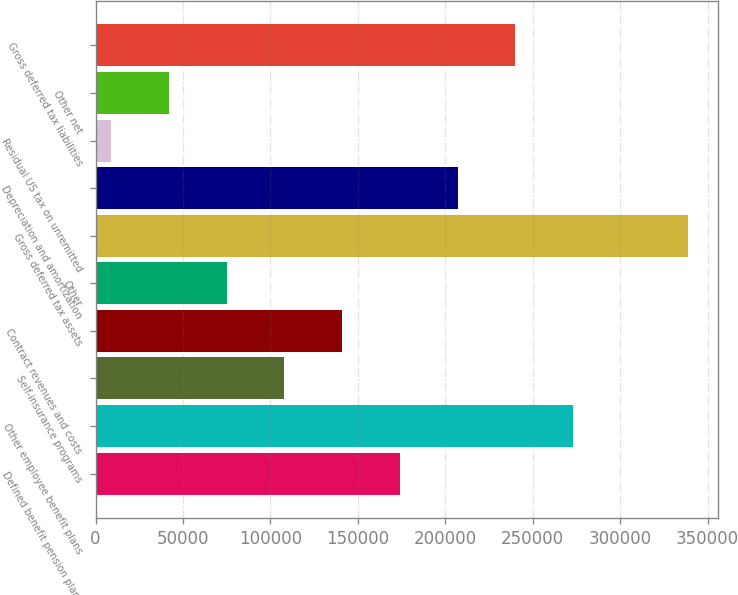<chart> <loc_0><loc_0><loc_500><loc_500><bar_chart><fcel>Defined benefit pension plans<fcel>Other employee benefit plans<fcel>Self-insurance programs<fcel>Contract revenues and costs<fcel>Other<fcel>Gross deferred tax assets<fcel>Depreciation and amortization<fcel>Residual US tax on unremitted<fcel>Other net<fcel>Gross deferred tax liabilities<nl><fcel>174006<fcel>272996<fcel>108014<fcel>141010<fcel>75017<fcel>338989<fcel>207003<fcel>9024<fcel>42020.5<fcel>240000<nl></chart> 